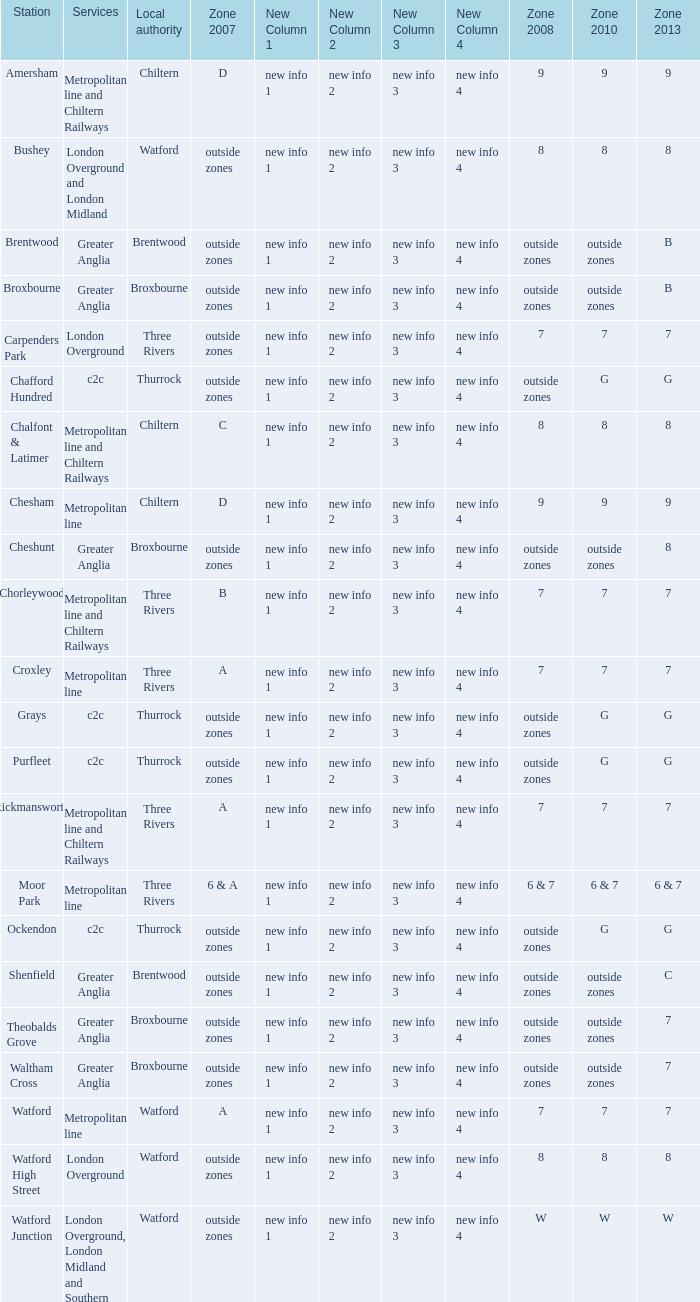Write the full table. {'header': ['Station', 'Services', 'Local authority', 'Zone 2007', 'New Column 1', 'New Column 2', 'New Column 3', 'New Column 4', 'Zone 2008', 'Zone 2010', 'Zone 2013'], 'rows': [['Amersham', 'Metropolitan line and Chiltern Railways', 'Chiltern', 'D', 'new info 1', 'new info 2', 'new info 3', 'new info 4', '9', '9', '9'], ['Bushey', 'London Overground and London Midland', 'Watford', 'outside zones', 'new info 1', 'new info 2', 'new info 3', 'new info 4', '8', '8', '8'], ['Brentwood', 'Greater Anglia', 'Brentwood', 'outside zones', 'new info 1', 'new info 2', 'new info 3', 'new info 4', 'outside zones', 'outside zones', 'B'], ['Broxbourne', 'Greater Anglia', 'Broxbourne', 'outside zones', 'new info 1', 'new info 2', 'new info 3', 'new info 4', 'outside zones', 'outside zones', 'B'], ['Carpenders Park', 'London Overground', 'Three Rivers', 'outside zones', 'new info 1', 'new info 2', 'new info 3', 'new info 4', '7', '7', '7'], ['Chafford Hundred', 'c2c', 'Thurrock', 'outside zones', 'new info 1', 'new info 2', 'new info 3', 'new info 4', 'outside zones', 'G', 'G'], ['Chalfont & Latimer', 'Metropolitan line and Chiltern Railways', 'Chiltern', 'C', 'new info 1', 'new info 2', 'new info 3', 'new info 4', '8', '8', '8'], ['Chesham', 'Metropolitan line', 'Chiltern', 'D', 'new info 1', 'new info 2', 'new info 3', 'new info 4', '9', '9', '9'], ['Cheshunt', 'Greater Anglia', 'Broxbourne', 'outside zones', 'new info 1', 'new info 2', 'new info 3', 'new info 4', 'outside zones', 'outside zones', '8'], ['Chorleywood', 'Metropolitan line and Chiltern Railways', 'Three Rivers', 'B', 'new info 1', 'new info 2', 'new info 3', 'new info 4', '7', '7', '7'], ['Croxley', 'Metropolitan line', 'Three Rivers', 'A', 'new info 1', 'new info 2', 'new info 3', 'new info 4', '7', '7', '7'], ['Grays', 'c2c', 'Thurrock', 'outside zones', 'new info 1', 'new info 2', 'new info 3', 'new info 4', 'outside zones', 'G', 'G'], ['Purfleet', 'c2c', 'Thurrock', 'outside zones', 'new info 1', 'new info 2', 'new info 3', 'new info 4', 'outside zones', 'G', 'G'], ['Rickmansworth', 'Metropolitan line and Chiltern Railways', 'Three Rivers', 'A', 'new info 1', 'new info 2', 'new info 3', 'new info 4', '7', '7', '7'], ['Moor Park', 'Metropolitan line', 'Three Rivers', '6 & A', 'new info 1', 'new info 2', 'new info 3', 'new info 4', '6 & 7', '6 & 7', '6 & 7'], ['Ockendon', 'c2c', 'Thurrock', 'outside zones', 'new info 1', 'new info 2', 'new info 3', 'new info 4', 'outside zones', 'G', 'G'], ['Shenfield', 'Greater Anglia', 'Brentwood', 'outside zones', 'new info 1', 'new info 2', 'new info 3', 'new info 4', 'outside zones', 'outside zones', 'C'], ['Theobalds Grove', 'Greater Anglia', 'Broxbourne', 'outside zones', 'new info 1', 'new info 2', 'new info 3', 'new info 4', 'outside zones', 'outside zones', '7'], ['Waltham Cross', 'Greater Anglia', 'Broxbourne', 'outside zones', 'new info 1', 'new info 2', 'new info 3', 'new info 4', 'outside zones', 'outside zones', '7'], ['Watford', 'Metropolitan line', 'Watford', 'A', 'new info 1', 'new info 2', 'new info 3', 'new info 4', '7', '7', '7'], ['Watford High Street', 'London Overground', 'Watford', 'outside zones', 'new info 1', 'new info 2', 'new info 3', 'new info 4', '8', '8', '8'], ['Watford Junction', 'London Overground, London Midland and Southern', 'Watford', 'outside zones', 'new info 1', 'new info 2', 'new info 3', 'new info 4', 'W', 'W', 'W']]} Which Local authority has a Zone 2007 of outside zones, and a Zone 2008 of outside zones, and a Zone 2010 of outside zones, and a Station of waltham cross? Broxbourne. 